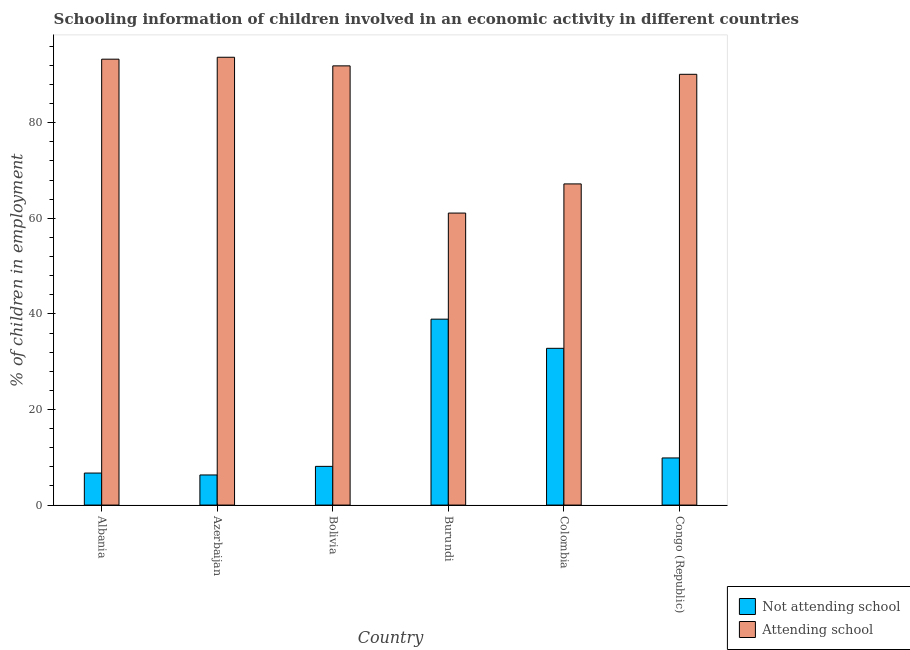How many different coloured bars are there?
Give a very brief answer. 2. How many groups of bars are there?
Your answer should be compact. 6. Are the number of bars per tick equal to the number of legend labels?
Offer a terse response. Yes. What is the label of the 4th group of bars from the left?
Provide a succinct answer. Burundi. In how many cases, is the number of bars for a given country not equal to the number of legend labels?
Ensure brevity in your answer.  0. What is the percentage of employed children who are not attending school in Bolivia?
Keep it short and to the point. 8.1. Across all countries, what is the maximum percentage of employed children who are not attending school?
Provide a short and direct response. 38.9. Across all countries, what is the minimum percentage of employed children who are attending school?
Your answer should be compact. 61.1. In which country was the percentage of employed children who are attending school maximum?
Your response must be concise. Azerbaijan. In which country was the percentage of employed children who are not attending school minimum?
Keep it short and to the point. Azerbaijan. What is the total percentage of employed children who are attending school in the graph?
Your answer should be compact. 497.33. What is the difference between the percentage of employed children who are attending school in Bolivia and that in Burundi?
Make the answer very short. 30.8. What is the difference between the percentage of employed children who are not attending school in Congo (Republic) and the percentage of employed children who are attending school in Azerbaijan?
Keep it short and to the point. -83.84. What is the average percentage of employed children who are attending school per country?
Make the answer very short. 82.89. What is the difference between the percentage of employed children who are not attending school and percentage of employed children who are attending school in Albania?
Ensure brevity in your answer.  -86.6. What is the ratio of the percentage of employed children who are not attending school in Colombia to that in Congo (Republic)?
Your response must be concise. 3.33. What is the difference between the highest and the second highest percentage of employed children who are attending school?
Your answer should be compact. 0.4. What is the difference between the highest and the lowest percentage of employed children who are not attending school?
Your answer should be compact. 32.6. Is the sum of the percentage of employed children who are not attending school in Albania and Colombia greater than the maximum percentage of employed children who are attending school across all countries?
Make the answer very short. No. What does the 1st bar from the left in Bolivia represents?
Keep it short and to the point. Not attending school. What does the 1st bar from the right in Colombia represents?
Your answer should be compact. Attending school. How many bars are there?
Offer a very short reply. 12. Are all the bars in the graph horizontal?
Offer a terse response. No. Are the values on the major ticks of Y-axis written in scientific E-notation?
Provide a short and direct response. No. Does the graph contain any zero values?
Provide a short and direct response. No. Does the graph contain grids?
Keep it short and to the point. No. Where does the legend appear in the graph?
Ensure brevity in your answer.  Bottom right. How many legend labels are there?
Offer a very short reply. 2. What is the title of the graph?
Ensure brevity in your answer.  Schooling information of children involved in an economic activity in different countries. What is the label or title of the X-axis?
Keep it short and to the point. Country. What is the label or title of the Y-axis?
Provide a succinct answer. % of children in employment. What is the % of children in employment in Not attending school in Albania?
Provide a short and direct response. 6.7. What is the % of children in employment of Attending school in Albania?
Your answer should be very brief. 93.3. What is the % of children in employment in Attending school in Azerbaijan?
Your answer should be very brief. 93.7. What is the % of children in employment of Not attending school in Bolivia?
Keep it short and to the point. 8.1. What is the % of children in employment of Attending school in Bolivia?
Provide a succinct answer. 91.9. What is the % of children in employment of Not attending school in Burundi?
Offer a very short reply. 38.9. What is the % of children in employment in Attending school in Burundi?
Offer a very short reply. 61.1. What is the % of children in employment in Not attending school in Colombia?
Your response must be concise. 32.8. What is the % of children in employment of Attending school in Colombia?
Ensure brevity in your answer.  67.2. What is the % of children in employment of Not attending school in Congo (Republic)?
Make the answer very short. 9.86. What is the % of children in employment in Attending school in Congo (Republic)?
Your response must be concise. 90.14. Across all countries, what is the maximum % of children in employment in Not attending school?
Provide a short and direct response. 38.9. Across all countries, what is the maximum % of children in employment in Attending school?
Offer a very short reply. 93.7. Across all countries, what is the minimum % of children in employment in Not attending school?
Offer a very short reply. 6.3. Across all countries, what is the minimum % of children in employment in Attending school?
Keep it short and to the point. 61.1. What is the total % of children in employment of Not attending school in the graph?
Your response must be concise. 102.66. What is the total % of children in employment in Attending school in the graph?
Ensure brevity in your answer.  497.33. What is the difference between the % of children in employment in Attending school in Albania and that in Azerbaijan?
Ensure brevity in your answer.  -0.4. What is the difference between the % of children in employment in Attending school in Albania and that in Bolivia?
Ensure brevity in your answer.  1.4. What is the difference between the % of children in employment of Not attending school in Albania and that in Burundi?
Your response must be concise. -32.2. What is the difference between the % of children in employment of Attending school in Albania and that in Burundi?
Offer a terse response. 32.2. What is the difference between the % of children in employment of Not attending school in Albania and that in Colombia?
Provide a succinct answer. -26.1. What is the difference between the % of children in employment in Attending school in Albania and that in Colombia?
Ensure brevity in your answer.  26.1. What is the difference between the % of children in employment of Not attending school in Albania and that in Congo (Republic)?
Make the answer very short. -3.16. What is the difference between the % of children in employment in Attending school in Albania and that in Congo (Republic)?
Make the answer very short. 3.17. What is the difference between the % of children in employment of Not attending school in Azerbaijan and that in Bolivia?
Give a very brief answer. -1.8. What is the difference between the % of children in employment of Not attending school in Azerbaijan and that in Burundi?
Make the answer very short. -32.6. What is the difference between the % of children in employment of Attending school in Azerbaijan and that in Burundi?
Keep it short and to the point. 32.6. What is the difference between the % of children in employment of Not attending school in Azerbaijan and that in Colombia?
Provide a succinct answer. -26.5. What is the difference between the % of children in employment of Not attending school in Azerbaijan and that in Congo (Republic)?
Keep it short and to the point. -3.56. What is the difference between the % of children in employment of Attending school in Azerbaijan and that in Congo (Republic)?
Your answer should be very brief. 3.56. What is the difference between the % of children in employment of Not attending school in Bolivia and that in Burundi?
Offer a very short reply. -30.8. What is the difference between the % of children in employment in Attending school in Bolivia and that in Burundi?
Provide a short and direct response. 30.8. What is the difference between the % of children in employment in Not attending school in Bolivia and that in Colombia?
Your answer should be compact. -24.7. What is the difference between the % of children in employment in Attending school in Bolivia and that in Colombia?
Give a very brief answer. 24.7. What is the difference between the % of children in employment in Not attending school in Bolivia and that in Congo (Republic)?
Offer a terse response. -1.76. What is the difference between the % of children in employment in Attending school in Bolivia and that in Congo (Republic)?
Make the answer very short. 1.76. What is the difference between the % of children in employment in Not attending school in Burundi and that in Colombia?
Provide a succinct answer. 6.1. What is the difference between the % of children in employment of Attending school in Burundi and that in Colombia?
Ensure brevity in your answer.  -6.1. What is the difference between the % of children in employment in Not attending school in Burundi and that in Congo (Republic)?
Ensure brevity in your answer.  29.04. What is the difference between the % of children in employment of Attending school in Burundi and that in Congo (Republic)?
Your answer should be compact. -29.04. What is the difference between the % of children in employment in Not attending school in Colombia and that in Congo (Republic)?
Offer a very short reply. 22.94. What is the difference between the % of children in employment in Attending school in Colombia and that in Congo (Republic)?
Give a very brief answer. -22.93. What is the difference between the % of children in employment in Not attending school in Albania and the % of children in employment in Attending school in Azerbaijan?
Provide a short and direct response. -87. What is the difference between the % of children in employment in Not attending school in Albania and the % of children in employment in Attending school in Bolivia?
Your answer should be very brief. -85.2. What is the difference between the % of children in employment in Not attending school in Albania and the % of children in employment in Attending school in Burundi?
Give a very brief answer. -54.4. What is the difference between the % of children in employment of Not attending school in Albania and the % of children in employment of Attending school in Colombia?
Offer a terse response. -60.5. What is the difference between the % of children in employment of Not attending school in Albania and the % of children in employment of Attending school in Congo (Republic)?
Ensure brevity in your answer.  -83.44. What is the difference between the % of children in employment of Not attending school in Azerbaijan and the % of children in employment of Attending school in Bolivia?
Offer a terse response. -85.6. What is the difference between the % of children in employment of Not attending school in Azerbaijan and the % of children in employment of Attending school in Burundi?
Offer a terse response. -54.8. What is the difference between the % of children in employment in Not attending school in Azerbaijan and the % of children in employment in Attending school in Colombia?
Keep it short and to the point. -60.9. What is the difference between the % of children in employment of Not attending school in Azerbaijan and the % of children in employment of Attending school in Congo (Republic)?
Give a very brief answer. -83.83. What is the difference between the % of children in employment of Not attending school in Bolivia and the % of children in employment of Attending school in Burundi?
Your answer should be very brief. -53. What is the difference between the % of children in employment of Not attending school in Bolivia and the % of children in employment of Attending school in Colombia?
Provide a succinct answer. -59.1. What is the difference between the % of children in employment in Not attending school in Bolivia and the % of children in employment in Attending school in Congo (Republic)?
Your answer should be very brief. -82.03. What is the difference between the % of children in employment in Not attending school in Burundi and the % of children in employment in Attending school in Colombia?
Ensure brevity in your answer.  -28.3. What is the difference between the % of children in employment of Not attending school in Burundi and the % of children in employment of Attending school in Congo (Republic)?
Give a very brief answer. -51.23. What is the difference between the % of children in employment of Not attending school in Colombia and the % of children in employment of Attending school in Congo (Republic)?
Your response must be concise. -57.34. What is the average % of children in employment of Not attending school per country?
Ensure brevity in your answer.  17.11. What is the average % of children in employment of Attending school per country?
Make the answer very short. 82.89. What is the difference between the % of children in employment in Not attending school and % of children in employment in Attending school in Albania?
Your response must be concise. -86.6. What is the difference between the % of children in employment in Not attending school and % of children in employment in Attending school in Azerbaijan?
Offer a very short reply. -87.4. What is the difference between the % of children in employment of Not attending school and % of children in employment of Attending school in Bolivia?
Ensure brevity in your answer.  -83.8. What is the difference between the % of children in employment in Not attending school and % of children in employment in Attending school in Burundi?
Offer a terse response. -22.2. What is the difference between the % of children in employment of Not attending school and % of children in employment of Attending school in Colombia?
Your answer should be very brief. -34.4. What is the difference between the % of children in employment of Not attending school and % of children in employment of Attending school in Congo (Republic)?
Offer a very short reply. -80.28. What is the ratio of the % of children in employment in Not attending school in Albania to that in Azerbaijan?
Keep it short and to the point. 1.06. What is the ratio of the % of children in employment in Attending school in Albania to that in Azerbaijan?
Ensure brevity in your answer.  1. What is the ratio of the % of children in employment in Not attending school in Albania to that in Bolivia?
Your response must be concise. 0.83. What is the ratio of the % of children in employment of Attending school in Albania to that in Bolivia?
Keep it short and to the point. 1.02. What is the ratio of the % of children in employment in Not attending school in Albania to that in Burundi?
Make the answer very short. 0.17. What is the ratio of the % of children in employment in Attending school in Albania to that in Burundi?
Offer a very short reply. 1.53. What is the ratio of the % of children in employment in Not attending school in Albania to that in Colombia?
Offer a very short reply. 0.2. What is the ratio of the % of children in employment of Attending school in Albania to that in Colombia?
Your answer should be compact. 1.39. What is the ratio of the % of children in employment of Not attending school in Albania to that in Congo (Republic)?
Provide a succinct answer. 0.68. What is the ratio of the % of children in employment of Attending school in Albania to that in Congo (Republic)?
Offer a very short reply. 1.04. What is the ratio of the % of children in employment in Attending school in Azerbaijan to that in Bolivia?
Keep it short and to the point. 1.02. What is the ratio of the % of children in employment of Not attending school in Azerbaijan to that in Burundi?
Offer a very short reply. 0.16. What is the ratio of the % of children in employment of Attending school in Azerbaijan to that in Burundi?
Give a very brief answer. 1.53. What is the ratio of the % of children in employment of Not attending school in Azerbaijan to that in Colombia?
Provide a short and direct response. 0.19. What is the ratio of the % of children in employment of Attending school in Azerbaijan to that in Colombia?
Your answer should be compact. 1.39. What is the ratio of the % of children in employment in Not attending school in Azerbaijan to that in Congo (Republic)?
Your answer should be compact. 0.64. What is the ratio of the % of children in employment of Attending school in Azerbaijan to that in Congo (Republic)?
Keep it short and to the point. 1.04. What is the ratio of the % of children in employment in Not attending school in Bolivia to that in Burundi?
Your response must be concise. 0.21. What is the ratio of the % of children in employment in Attending school in Bolivia to that in Burundi?
Provide a short and direct response. 1.5. What is the ratio of the % of children in employment in Not attending school in Bolivia to that in Colombia?
Make the answer very short. 0.25. What is the ratio of the % of children in employment of Attending school in Bolivia to that in Colombia?
Offer a terse response. 1.37. What is the ratio of the % of children in employment in Not attending school in Bolivia to that in Congo (Republic)?
Provide a succinct answer. 0.82. What is the ratio of the % of children in employment in Attending school in Bolivia to that in Congo (Republic)?
Keep it short and to the point. 1.02. What is the ratio of the % of children in employment of Not attending school in Burundi to that in Colombia?
Your response must be concise. 1.19. What is the ratio of the % of children in employment of Attending school in Burundi to that in Colombia?
Make the answer very short. 0.91. What is the ratio of the % of children in employment of Not attending school in Burundi to that in Congo (Republic)?
Your answer should be compact. 3.95. What is the ratio of the % of children in employment of Attending school in Burundi to that in Congo (Republic)?
Your answer should be very brief. 0.68. What is the ratio of the % of children in employment in Not attending school in Colombia to that in Congo (Republic)?
Ensure brevity in your answer.  3.33. What is the ratio of the % of children in employment of Attending school in Colombia to that in Congo (Republic)?
Your response must be concise. 0.75. What is the difference between the highest and the second highest % of children in employment of Attending school?
Make the answer very short. 0.4. What is the difference between the highest and the lowest % of children in employment in Not attending school?
Your answer should be very brief. 32.6. What is the difference between the highest and the lowest % of children in employment of Attending school?
Provide a short and direct response. 32.6. 